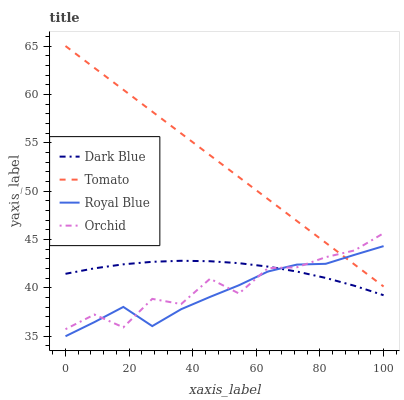Does Royal Blue have the minimum area under the curve?
Answer yes or no. Yes. Does Tomato have the maximum area under the curve?
Answer yes or no. Yes. Does Dark Blue have the minimum area under the curve?
Answer yes or no. No. Does Dark Blue have the maximum area under the curve?
Answer yes or no. No. Is Tomato the smoothest?
Answer yes or no. Yes. Is Orchid the roughest?
Answer yes or no. Yes. Is Dark Blue the smoothest?
Answer yes or no. No. Is Dark Blue the roughest?
Answer yes or no. No. Does Dark Blue have the lowest value?
Answer yes or no. No. Does Orchid have the highest value?
Answer yes or no. No. Is Dark Blue less than Tomato?
Answer yes or no. Yes. Is Tomato greater than Dark Blue?
Answer yes or no. Yes. Does Dark Blue intersect Tomato?
Answer yes or no. No. 